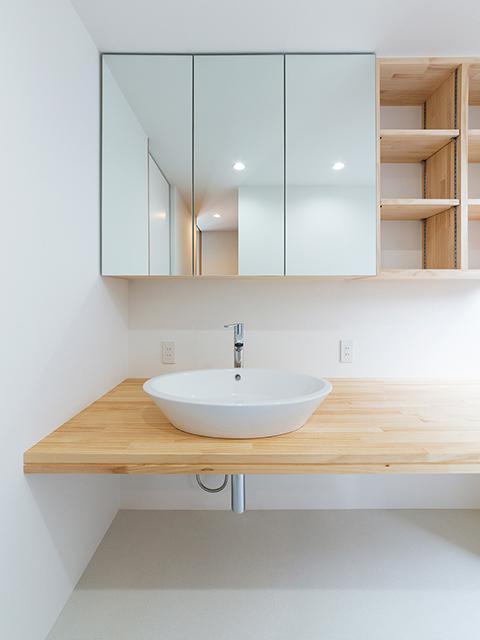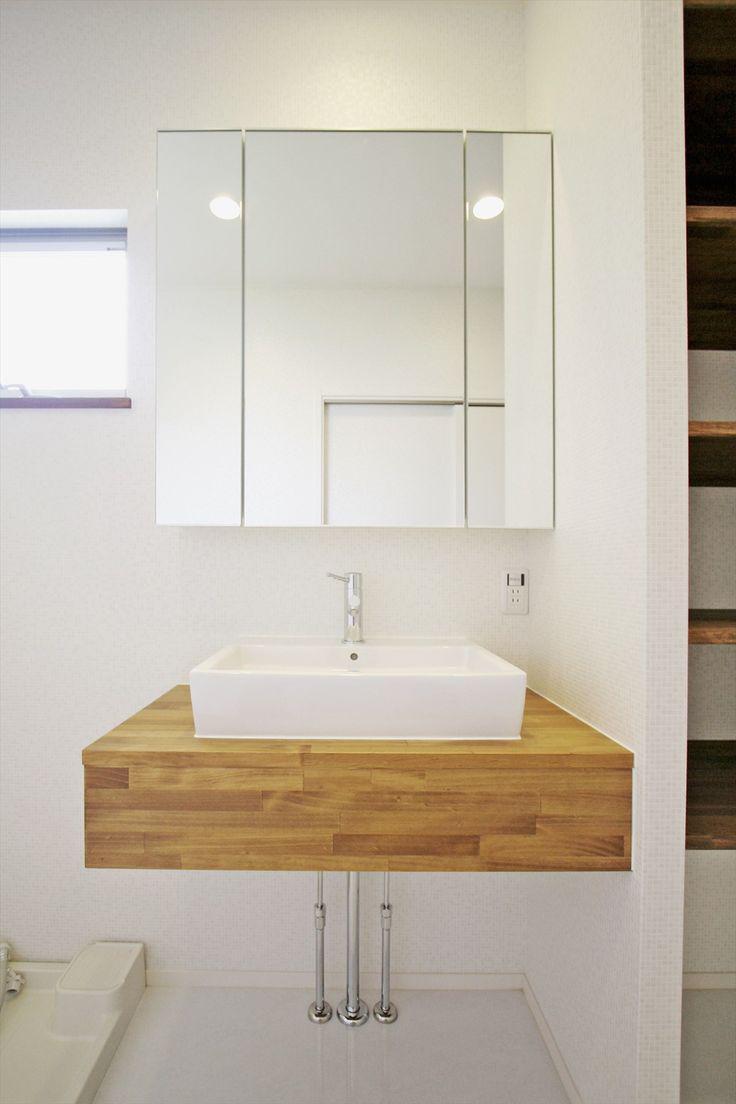The first image is the image on the left, the second image is the image on the right. Given the left and right images, does the statement "One sink is a rectangular bowl." hold true? Answer yes or no. Yes. The first image is the image on the left, the second image is the image on the right. For the images displayed, is the sentence "At least one of the images shows a washbasin on a wooden shelf." factually correct? Answer yes or no. Yes. 